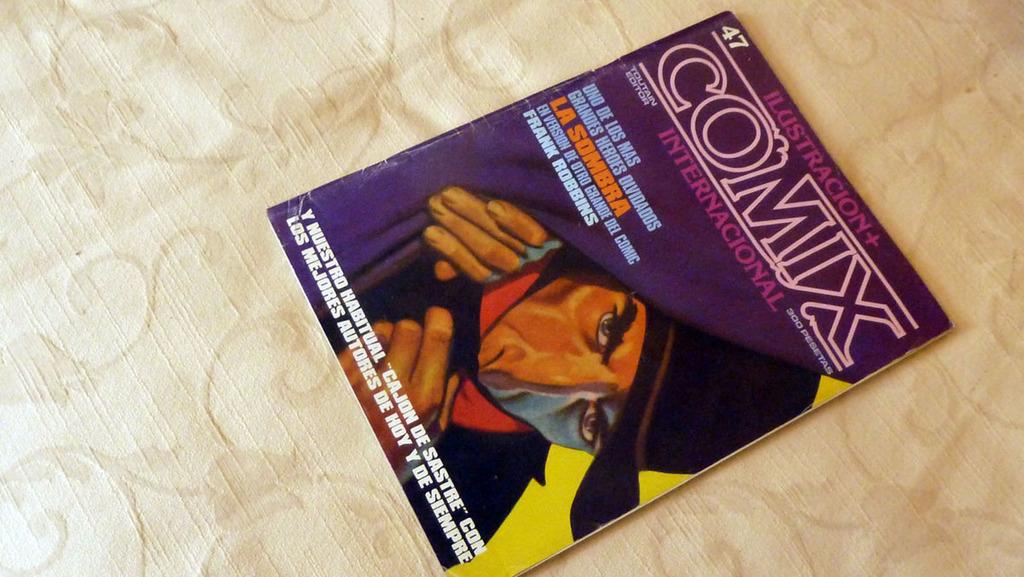<image>
Create a compact narrative representing the image presented. A magazine called Comix sits on a table. 